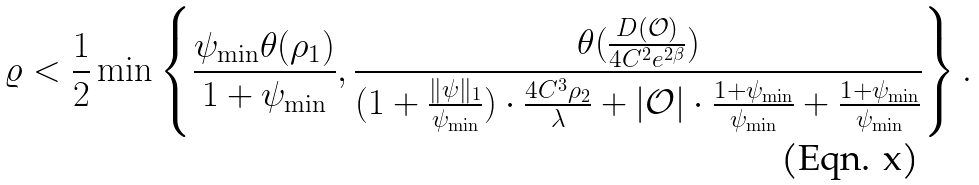<formula> <loc_0><loc_0><loc_500><loc_500>\varrho < \frac { 1 } { 2 } \min \left \{ \frac { \psi _ { \min } \theta ( \rho _ { 1 } ) } { 1 + \psi _ { \min } } , \frac { \theta ( \frac { D ( \mathcal { O } ) } { 4 C ^ { 2 } e ^ { 2 \beta } } ) } { ( 1 + \frac { \| \psi \| _ { 1 } } { \psi _ { \min } } ) \cdot \frac { 4 C ^ { 3 } \rho _ { 2 } } { \lambda } + | \mathcal { O } | \cdot \frac { 1 + \psi _ { \min } } { \psi _ { \min } } + \frac { 1 + \psi _ { \min } } { \psi _ { \min } } } \right \} .</formula> 